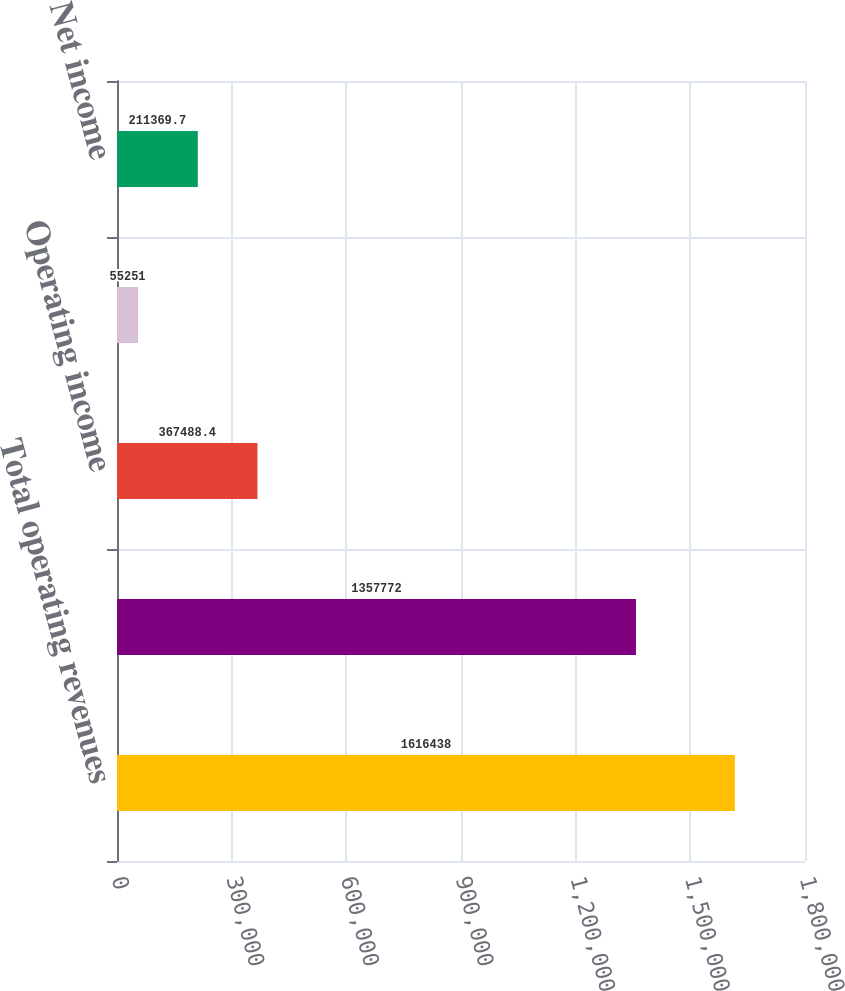<chart> <loc_0><loc_0><loc_500><loc_500><bar_chart><fcel>Total operating revenues<fcel>Total operating expenses<fcel>Operating income<fcel>Other expenses net<fcel>Net income<nl><fcel>1.61644e+06<fcel>1.35777e+06<fcel>367488<fcel>55251<fcel>211370<nl></chart> 